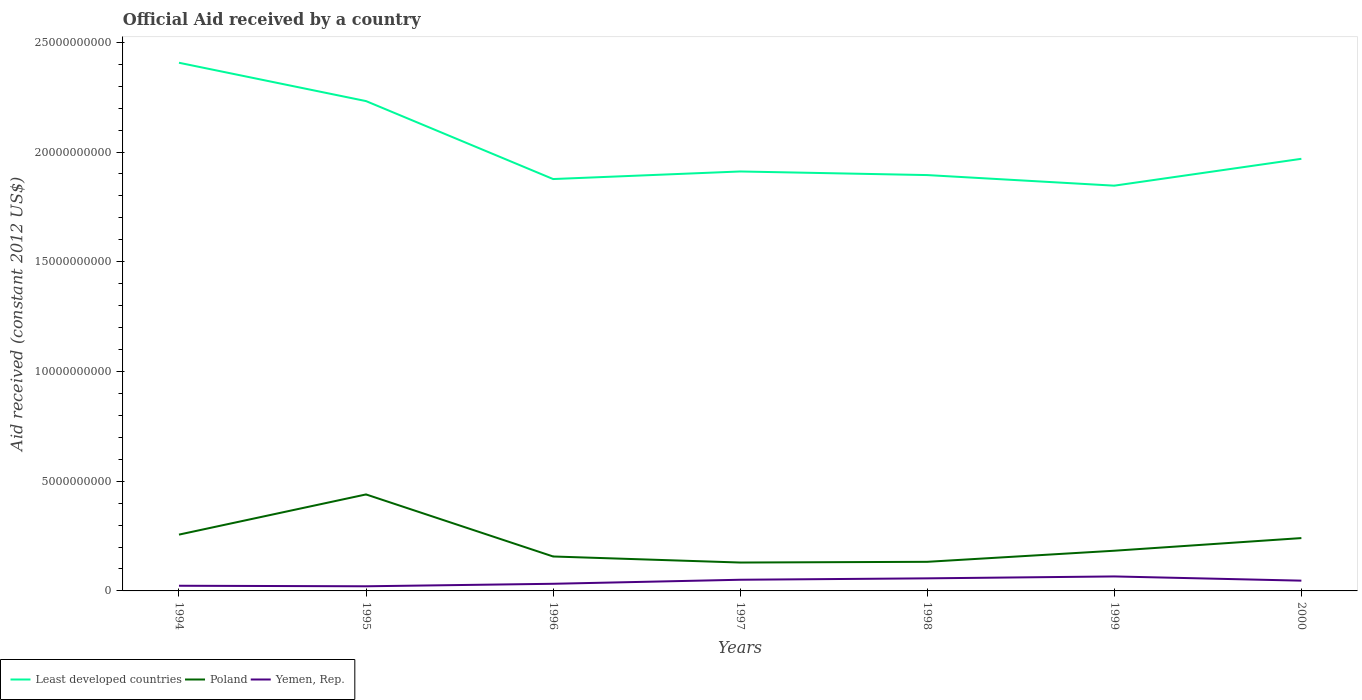Is the number of lines equal to the number of legend labels?
Keep it short and to the point. Yes. Across all years, what is the maximum net official aid received in Least developed countries?
Your answer should be compact. 1.85e+1. What is the total net official aid received in Least developed countries in the graph?
Make the answer very short. 4.38e+09. What is the difference between the highest and the second highest net official aid received in Poland?
Offer a very short reply. 3.10e+09. What is the difference between the highest and the lowest net official aid received in Poland?
Your answer should be very brief. 3. Is the net official aid received in Least developed countries strictly greater than the net official aid received in Yemen, Rep. over the years?
Your response must be concise. No. How many years are there in the graph?
Give a very brief answer. 7. What is the difference between two consecutive major ticks on the Y-axis?
Ensure brevity in your answer.  5.00e+09. Where does the legend appear in the graph?
Ensure brevity in your answer.  Bottom left. How many legend labels are there?
Provide a short and direct response. 3. How are the legend labels stacked?
Offer a terse response. Horizontal. What is the title of the graph?
Make the answer very short. Official Aid received by a country. Does "Channel Islands" appear as one of the legend labels in the graph?
Ensure brevity in your answer.  No. What is the label or title of the X-axis?
Make the answer very short. Years. What is the label or title of the Y-axis?
Offer a terse response. Aid received (constant 2012 US$). What is the Aid received (constant 2012 US$) in Least developed countries in 1994?
Keep it short and to the point. 2.41e+1. What is the Aid received (constant 2012 US$) in Poland in 1994?
Give a very brief answer. 2.57e+09. What is the Aid received (constant 2012 US$) of Yemen, Rep. in 1994?
Provide a short and direct response. 2.36e+08. What is the Aid received (constant 2012 US$) of Least developed countries in 1995?
Your answer should be compact. 2.23e+1. What is the Aid received (constant 2012 US$) in Poland in 1995?
Your response must be concise. 4.40e+09. What is the Aid received (constant 2012 US$) of Yemen, Rep. in 1995?
Keep it short and to the point. 2.12e+08. What is the Aid received (constant 2012 US$) in Least developed countries in 1996?
Give a very brief answer. 1.88e+1. What is the Aid received (constant 2012 US$) of Poland in 1996?
Make the answer very short. 1.57e+09. What is the Aid received (constant 2012 US$) of Yemen, Rep. in 1996?
Provide a succinct answer. 3.26e+08. What is the Aid received (constant 2012 US$) of Least developed countries in 1997?
Make the answer very short. 1.91e+1. What is the Aid received (constant 2012 US$) of Poland in 1997?
Your answer should be compact. 1.29e+09. What is the Aid received (constant 2012 US$) in Yemen, Rep. in 1997?
Your answer should be very brief. 5.09e+08. What is the Aid received (constant 2012 US$) in Least developed countries in 1998?
Keep it short and to the point. 1.89e+1. What is the Aid received (constant 2012 US$) of Poland in 1998?
Your response must be concise. 1.33e+09. What is the Aid received (constant 2012 US$) in Yemen, Rep. in 1998?
Your answer should be compact. 5.73e+08. What is the Aid received (constant 2012 US$) of Least developed countries in 1999?
Your response must be concise. 1.85e+1. What is the Aid received (constant 2012 US$) in Poland in 1999?
Ensure brevity in your answer.  1.83e+09. What is the Aid received (constant 2012 US$) of Yemen, Rep. in 1999?
Your answer should be very brief. 6.60e+08. What is the Aid received (constant 2012 US$) of Least developed countries in 2000?
Give a very brief answer. 1.97e+1. What is the Aid received (constant 2012 US$) of Poland in 2000?
Make the answer very short. 2.41e+09. What is the Aid received (constant 2012 US$) in Yemen, Rep. in 2000?
Provide a short and direct response. 4.68e+08. Across all years, what is the maximum Aid received (constant 2012 US$) in Least developed countries?
Your answer should be compact. 2.41e+1. Across all years, what is the maximum Aid received (constant 2012 US$) of Poland?
Provide a short and direct response. 4.40e+09. Across all years, what is the maximum Aid received (constant 2012 US$) in Yemen, Rep.?
Your answer should be very brief. 6.60e+08. Across all years, what is the minimum Aid received (constant 2012 US$) of Least developed countries?
Make the answer very short. 1.85e+1. Across all years, what is the minimum Aid received (constant 2012 US$) in Poland?
Your response must be concise. 1.29e+09. Across all years, what is the minimum Aid received (constant 2012 US$) in Yemen, Rep.?
Give a very brief answer. 2.12e+08. What is the total Aid received (constant 2012 US$) in Least developed countries in the graph?
Your answer should be very brief. 1.41e+11. What is the total Aid received (constant 2012 US$) in Poland in the graph?
Ensure brevity in your answer.  1.54e+1. What is the total Aid received (constant 2012 US$) of Yemen, Rep. in the graph?
Your response must be concise. 2.98e+09. What is the difference between the Aid received (constant 2012 US$) in Least developed countries in 1994 and that in 1995?
Offer a terse response. 1.75e+09. What is the difference between the Aid received (constant 2012 US$) of Poland in 1994 and that in 1995?
Your answer should be compact. -1.83e+09. What is the difference between the Aid received (constant 2012 US$) of Yemen, Rep. in 1994 and that in 1995?
Your answer should be compact. 2.44e+07. What is the difference between the Aid received (constant 2012 US$) of Least developed countries in 1994 and that in 1996?
Provide a short and direct response. 5.30e+09. What is the difference between the Aid received (constant 2012 US$) in Poland in 1994 and that in 1996?
Your response must be concise. 9.96e+08. What is the difference between the Aid received (constant 2012 US$) of Yemen, Rep. in 1994 and that in 1996?
Your answer should be compact. -8.98e+07. What is the difference between the Aid received (constant 2012 US$) of Least developed countries in 1994 and that in 1997?
Offer a terse response. 4.95e+09. What is the difference between the Aid received (constant 2012 US$) in Poland in 1994 and that in 1997?
Your response must be concise. 1.27e+09. What is the difference between the Aid received (constant 2012 US$) in Yemen, Rep. in 1994 and that in 1997?
Provide a succinct answer. -2.73e+08. What is the difference between the Aid received (constant 2012 US$) in Least developed countries in 1994 and that in 1998?
Keep it short and to the point. 5.12e+09. What is the difference between the Aid received (constant 2012 US$) in Poland in 1994 and that in 1998?
Provide a succinct answer. 1.24e+09. What is the difference between the Aid received (constant 2012 US$) of Yemen, Rep. in 1994 and that in 1998?
Offer a terse response. -3.37e+08. What is the difference between the Aid received (constant 2012 US$) of Least developed countries in 1994 and that in 1999?
Your answer should be compact. 5.60e+09. What is the difference between the Aid received (constant 2012 US$) in Poland in 1994 and that in 1999?
Make the answer very short. 7.34e+08. What is the difference between the Aid received (constant 2012 US$) of Yemen, Rep. in 1994 and that in 1999?
Keep it short and to the point. -4.24e+08. What is the difference between the Aid received (constant 2012 US$) of Least developed countries in 1994 and that in 2000?
Your answer should be very brief. 4.38e+09. What is the difference between the Aid received (constant 2012 US$) of Poland in 1994 and that in 2000?
Make the answer very short. 1.58e+08. What is the difference between the Aid received (constant 2012 US$) in Yemen, Rep. in 1994 and that in 2000?
Provide a succinct answer. -2.32e+08. What is the difference between the Aid received (constant 2012 US$) of Least developed countries in 1995 and that in 1996?
Keep it short and to the point. 3.55e+09. What is the difference between the Aid received (constant 2012 US$) in Poland in 1995 and that in 1996?
Your response must be concise. 2.83e+09. What is the difference between the Aid received (constant 2012 US$) of Yemen, Rep. in 1995 and that in 1996?
Keep it short and to the point. -1.14e+08. What is the difference between the Aid received (constant 2012 US$) of Least developed countries in 1995 and that in 1997?
Provide a short and direct response. 3.21e+09. What is the difference between the Aid received (constant 2012 US$) in Poland in 1995 and that in 1997?
Your response must be concise. 3.10e+09. What is the difference between the Aid received (constant 2012 US$) of Yemen, Rep. in 1995 and that in 1997?
Your response must be concise. -2.98e+08. What is the difference between the Aid received (constant 2012 US$) in Least developed countries in 1995 and that in 1998?
Ensure brevity in your answer.  3.37e+09. What is the difference between the Aid received (constant 2012 US$) of Poland in 1995 and that in 1998?
Give a very brief answer. 3.07e+09. What is the difference between the Aid received (constant 2012 US$) in Yemen, Rep. in 1995 and that in 1998?
Keep it short and to the point. -3.62e+08. What is the difference between the Aid received (constant 2012 US$) in Least developed countries in 1995 and that in 1999?
Make the answer very short. 3.85e+09. What is the difference between the Aid received (constant 2012 US$) of Poland in 1995 and that in 1999?
Ensure brevity in your answer.  2.57e+09. What is the difference between the Aid received (constant 2012 US$) in Yemen, Rep. in 1995 and that in 1999?
Give a very brief answer. -4.49e+08. What is the difference between the Aid received (constant 2012 US$) of Least developed countries in 1995 and that in 2000?
Make the answer very short. 2.63e+09. What is the difference between the Aid received (constant 2012 US$) of Poland in 1995 and that in 2000?
Offer a very short reply. 1.99e+09. What is the difference between the Aid received (constant 2012 US$) in Yemen, Rep. in 1995 and that in 2000?
Make the answer very short. -2.56e+08. What is the difference between the Aid received (constant 2012 US$) in Least developed countries in 1996 and that in 1997?
Offer a terse response. -3.45e+08. What is the difference between the Aid received (constant 2012 US$) of Poland in 1996 and that in 1997?
Provide a short and direct response. 2.76e+08. What is the difference between the Aid received (constant 2012 US$) of Yemen, Rep. in 1996 and that in 1997?
Make the answer very short. -1.83e+08. What is the difference between the Aid received (constant 2012 US$) of Least developed countries in 1996 and that in 1998?
Offer a very short reply. -1.81e+08. What is the difference between the Aid received (constant 2012 US$) in Poland in 1996 and that in 1998?
Your answer should be very brief. 2.43e+08. What is the difference between the Aid received (constant 2012 US$) of Yemen, Rep. in 1996 and that in 1998?
Provide a succinct answer. -2.48e+08. What is the difference between the Aid received (constant 2012 US$) of Least developed countries in 1996 and that in 1999?
Keep it short and to the point. 3.02e+08. What is the difference between the Aid received (constant 2012 US$) in Poland in 1996 and that in 1999?
Keep it short and to the point. -2.62e+08. What is the difference between the Aid received (constant 2012 US$) of Yemen, Rep. in 1996 and that in 1999?
Your answer should be compact. -3.34e+08. What is the difference between the Aid received (constant 2012 US$) of Least developed countries in 1996 and that in 2000?
Provide a short and direct response. -9.22e+08. What is the difference between the Aid received (constant 2012 US$) in Poland in 1996 and that in 2000?
Offer a terse response. -8.38e+08. What is the difference between the Aid received (constant 2012 US$) of Yemen, Rep. in 1996 and that in 2000?
Provide a succinct answer. -1.42e+08. What is the difference between the Aid received (constant 2012 US$) in Least developed countries in 1997 and that in 1998?
Your answer should be compact. 1.64e+08. What is the difference between the Aid received (constant 2012 US$) in Poland in 1997 and that in 1998?
Provide a short and direct response. -3.26e+07. What is the difference between the Aid received (constant 2012 US$) of Yemen, Rep. in 1997 and that in 1998?
Your response must be concise. -6.40e+07. What is the difference between the Aid received (constant 2012 US$) in Least developed countries in 1997 and that in 1999?
Offer a very short reply. 6.47e+08. What is the difference between the Aid received (constant 2012 US$) of Poland in 1997 and that in 1999?
Make the answer very short. -5.38e+08. What is the difference between the Aid received (constant 2012 US$) of Yemen, Rep. in 1997 and that in 1999?
Your answer should be very brief. -1.51e+08. What is the difference between the Aid received (constant 2012 US$) of Least developed countries in 1997 and that in 2000?
Your answer should be compact. -5.77e+08. What is the difference between the Aid received (constant 2012 US$) in Poland in 1997 and that in 2000?
Keep it short and to the point. -1.11e+09. What is the difference between the Aid received (constant 2012 US$) of Yemen, Rep. in 1997 and that in 2000?
Offer a terse response. 4.11e+07. What is the difference between the Aid received (constant 2012 US$) of Least developed countries in 1998 and that in 1999?
Your answer should be compact. 4.83e+08. What is the difference between the Aid received (constant 2012 US$) in Poland in 1998 and that in 1999?
Provide a succinct answer. -5.05e+08. What is the difference between the Aid received (constant 2012 US$) in Yemen, Rep. in 1998 and that in 1999?
Give a very brief answer. -8.70e+07. What is the difference between the Aid received (constant 2012 US$) in Least developed countries in 1998 and that in 2000?
Your answer should be very brief. -7.42e+08. What is the difference between the Aid received (constant 2012 US$) in Poland in 1998 and that in 2000?
Your answer should be very brief. -1.08e+09. What is the difference between the Aid received (constant 2012 US$) of Yemen, Rep. in 1998 and that in 2000?
Ensure brevity in your answer.  1.05e+08. What is the difference between the Aid received (constant 2012 US$) in Least developed countries in 1999 and that in 2000?
Make the answer very short. -1.22e+09. What is the difference between the Aid received (constant 2012 US$) in Poland in 1999 and that in 2000?
Offer a very short reply. -5.76e+08. What is the difference between the Aid received (constant 2012 US$) in Yemen, Rep. in 1999 and that in 2000?
Your response must be concise. 1.92e+08. What is the difference between the Aid received (constant 2012 US$) of Least developed countries in 1994 and the Aid received (constant 2012 US$) of Poland in 1995?
Your answer should be very brief. 1.97e+1. What is the difference between the Aid received (constant 2012 US$) of Least developed countries in 1994 and the Aid received (constant 2012 US$) of Yemen, Rep. in 1995?
Provide a short and direct response. 2.39e+1. What is the difference between the Aid received (constant 2012 US$) in Poland in 1994 and the Aid received (constant 2012 US$) in Yemen, Rep. in 1995?
Provide a short and direct response. 2.35e+09. What is the difference between the Aid received (constant 2012 US$) in Least developed countries in 1994 and the Aid received (constant 2012 US$) in Poland in 1996?
Provide a short and direct response. 2.25e+1. What is the difference between the Aid received (constant 2012 US$) of Least developed countries in 1994 and the Aid received (constant 2012 US$) of Yemen, Rep. in 1996?
Your answer should be very brief. 2.37e+1. What is the difference between the Aid received (constant 2012 US$) in Poland in 1994 and the Aid received (constant 2012 US$) in Yemen, Rep. in 1996?
Your answer should be compact. 2.24e+09. What is the difference between the Aid received (constant 2012 US$) in Least developed countries in 1994 and the Aid received (constant 2012 US$) in Poland in 1997?
Offer a terse response. 2.28e+1. What is the difference between the Aid received (constant 2012 US$) in Least developed countries in 1994 and the Aid received (constant 2012 US$) in Yemen, Rep. in 1997?
Make the answer very short. 2.36e+1. What is the difference between the Aid received (constant 2012 US$) in Poland in 1994 and the Aid received (constant 2012 US$) in Yemen, Rep. in 1997?
Ensure brevity in your answer.  2.06e+09. What is the difference between the Aid received (constant 2012 US$) of Least developed countries in 1994 and the Aid received (constant 2012 US$) of Poland in 1998?
Ensure brevity in your answer.  2.27e+1. What is the difference between the Aid received (constant 2012 US$) of Least developed countries in 1994 and the Aid received (constant 2012 US$) of Yemen, Rep. in 1998?
Make the answer very short. 2.35e+1. What is the difference between the Aid received (constant 2012 US$) in Poland in 1994 and the Aid received (constant 2012 US$) in Yemen, Rep. in 1998?
Offer a terse response. 1.99e+09. What is the difference between the Aid received (constant 2012 US$) of Least developed countries in 1994 and the Aid received (constant 2012 US$) of Poland in 1999?
Your answer should be very brief. 2.22e+1. What is the difference between the Aid received (constant 2012 US$) in Least developed countries in 1994 and the Aid received (constant 2012 US$) in Yemen, Rep. in 1999?
Provide a short and direct response. 2.34e+1. What is the difference between the Aid received (constant 2012 US$) in Poland in 1994 and the Aid received (constant 2012 US$) in Yemen, Rep. in 1999?
Provide a succinct answer. 1.91e+09. What is the difference between the Aid received (constant 2012 US$) in Least developed countries in 1994 and the Aid received (constant 2012 US$) in Poland in 2000?
Your answer should be compact. 2.17e+1. What is the difference between the Aid received (constant 2012 US$) of Least developed countries in 1994 and the Aid received (constant 2012 US$) of Yemen, Rep. in 2000?
Provide a succinct answer. 2.36e+1. What is the difference between the Aid received (constant 2012 US$) of Poland in 1994 and the Aid received (constant 2012 US$) of Yemen, Rep. in 2000?
Your answer should be very brief. 2.10e+09. What is the difference between the Aid received (constant 2012 US$) of Least developed countries in 1995 and the Aid received (constant 2012 US$) of Poland in 1996?
Offer a terse response. 2.08e+1. What is the difference between the Aid received (constant 2012 US$) of Least developed countries in 1995 and the Aid received (constant 2012 US$) of Yemen, Rep. in 1996?
Keep it short and to the point. 2.20e+1. What is the difference between the Aid received (constant 2012 US$) in Poland in 1995 and the Aid received (constant 2012 US$) in Yemen, Rep. in 1996?
Offer a terse response. 4.07e+09. What is the difference between the Aid received (constant 2012 US$) in Least developed countries in 1995 and the Aid received (constant 2012 US$) in Poland in 1997?
Your response must be concise. 2.10e+1. What is the difference between the Aid received (constant 2012 US$) in Least developed countries in 1995 and the Aid received (constant 2012 US$) in Yemen, Rep. in 1997?
Give a very brief answer. 2.18e+1. What is the difference between the Aid received (constant 2012 US$) of Poland in 1995 and the Aid received (constant 2012 US$) of Yemen, Rep. in 1997?
Offer a very short reply. 3.89e+09. What is the difference between the Aid received (constant 2012 US$) of Least developed countries in 1995 and the Aid received (constant 2012 US$) of Poland in 1998?
Ensure brevity in your answer.  2.10e+1. What is the difference between the Aid received (constant 2012 US$) of Least developed countries in 1995 and the Aid received (constant 2012 US$) of Yemen, Rep. in 1998?
Keep it short and to the point. 2.17e+1. What is the difference between the Aid received (constant 2012 US$) of Poland in 1995 and the Aid received (constant 2012 US$) of Yemen, Rep. in 1998?
Your answer should be compact. 3.82e+09. What is the difference between the Aid received (constant 2012 US$) in Least developed countries in 1995 and the Aid received (constant 2012 US$) in Poland in 1999?
Your answer should be very brief. 2.05e+1. What is the difference between the Aid received (constant 2012 US$) of Least developed countries in 1995 and the Aid received (constant 2012 US$) of Yemen, Rep. in 1999?
Make the answer very short. 2.17e+1. What is the difference between the Aid received (constant 2012 US$) of Poland in 1995 and the Aid received (constant 2012 US$) of Yemen, Rep. in 1999?
Your answer should be very brief. 3.74e+09. What is the difference between the Aid received (constant 2012 US$) of Least developed countries in 1995 and the Aid received (constant 2012 US$) of Poland in 2000?
Your response must be concise. 1.99e+1. What is the difference between the Aid received (constant 2012 US$) of Least developed countries in 1995 and the Aid received (constant 2012 US$) of Yemen, Rep. in 2000?
Offer a very short reply. 2.19e+1. What is the difference between the Aid received (constant 2012 US$) of Poland in 1995 and the Aid received (constant 2012 US$) of Yemen, Rep. in 2000?
Your answer should be compact. 3.93e+09. What is the difference between the Aid received (constant 2012 US$) of Least developed countries in 1996 and the Aid received (constant 2012 US$) of Poland in 1997?
Make the answer very short. 1.75e+1. What is the difference between the Aid received (constant 2012 US$) in Least developed countries in 1996 and the Aid received (constant 2012 US$) in Yemen, Rep. in 1997?
Offer a terse response. 1.83e+1. What is the difference between the Aid received (constant 2012 US$) in Poland in 1996 and the Aid received (constant 2012 US$) in Yemen, Rep. in 1997?
Your answer should be compact. 1.06e+09. What is the difference between the Aid received (constant 2012 US$) of Least developed countries in 1996 and the Aid received (constant 2012 US$) of Poland in 1998?
Your response must be concise. 1.74e+1. What is the difference between the Aid received (constant 2012 US$) of Least developed countries in 1996 and the Aid received (constant 2012 US$) of Yemen, Rep. in 1998?
Offer a terse response. 1.82e+1. What is the difference between the Aid received (constant 2012 US$) of Poland in 1996 and the Aid received (constant 2012 US$) of Yemen, Rep. in 1998?
Make the answer very short. 9.96e+08. What is the difference between the Aid received (constant 2012 US$) of Least developed countries in 1996 and the Aid received (constant 2012 US$) of Poland in 1999?
Offer a terse response. 1.69e+1. What is the difference between the Aid received (constant 2012 US$) in Least developed countries in 1996 and the Aid received (constant 2012 US$) in Yemen, Rep. in 1999?
Your answer should be compact. 1.81e+1. What is the difference between the Aid received (constant 2012 US$) of Poland in 1996 and the Aid received (constant 2012 US$) of Yemen, Rep. in 1999?
Your answer should be very brief. 9.09e+08. What is the difference between the Aid received (constant 2012 US$) of Least developed countries in 1996 and the Aid received (constant 2012 US$) of Poland in 2000?
Provide a succinct answer. 1.64e+1. What is the difference between the Aid received (constant 2012 US$) of Least developed countries in 1996 and the Aid received (constant 2012 US$) of Yemen, Rep. in 2000?
Offer a very short reply. 1.83e+1. What is the difference between the Aid received (constant 2012 US$) in Poland in 1996 and the Aid received (constant 2012 US$) in Yemen, Rep. in 2000?
Provide a short and direct response. 1.10e+09. What is the difference between the Aid received (constant 2012 US$) in Least developed countries in 1997 and the Aid received (constant 2012 US$) in Poland in 1998?
Keep it short and to the point. 1.78e+1. What is the difference between the Aid received (constant 2012 US$) of Least developed countries in 1997 and the Aid received (constant 2012 US$) of Yemen, Rep. in 1998?
Offer a terse response. 1.85e+1. What is the difference between the Aid received (constant 2012 US$) in Poland in 1997 and the Aid received (constant 2012 US$) in Yemen, Rep. in 1998?
Provide a short and direct response. 7.21e+08. What is the difference between the Aid received (constant 2012 US$) in Least developed countries in 1997 and the Aid received (constant 2012 US$) in Poland in 1999?
Give a very brief answer. 1.73e+1. What is the difference between the Aid received (constant 2012 US$) of Least developed countries in 1997 and the Aid received (constant 2012 US$) of Yemen, Rep. in 1999?
Offer a very short reply. 1.85e+1. What is the difference between the Aid received (constant 2012 US$) in Poland in 1997 and the Aid received (constant 2012 US$) in Yemen, Rep. in 1999?
Offer a terse response. 6.34e+08. What is the difference between the Aid received (constant 2012 US$) of Least developed countries in 1997 and the Aid received (constant 2012 US$) of Poland in 2000?
Provide a short and direct response. 1.67e+1. What is the difference between the Aid received (constant 2012 US$) in Least developed countries in 1997 and the Aid received (constant 2012 US$) in Yemen, Rep. in 2000?
Provide a succinct answer. 1.86e+1. What is the difference between the Aid received (constant 2012 US$) in Poland in 1997 and the Aid received (constant 2012 US$) in Yemen, Rep. in 2000?
Offer a terse response. 8.26e+08. What is the difference between the Aid received (constant 2012 US$) of Least developed countries in 1998 and the Aid received (constant 2012 US$) of Poland in 1999?
Provide a succinct answer. 1.71e+1. What is the difference between the Aid received (constant 2012 US$) in Least developed countries in 1998 and the Aid received (constant 2012 US$) in Yemen, Rep. in 1999?
Keep it short and to the point. 1.83e+1. What is the difference between the Aid received (constant 2012 US$) in Poland in 1998 and the Aid received (constant 2012 US$) in Yemen, Rep. in 1999?
Offer a terse response. 6.66e+08. What is the difference between the Aid received (constant 2012 US$) in Least developed countries in 1998 and the Aid received (constant 2012 US$) in Poland in 2000?
Keep it short and to the point. 1.65e+1. What is the difference between the Aid received (constant 2012 US$) of Least developed countries in 1998 and the Aid received (constant 2012 US$) of Yemen, Rep. in 2000?
Your response must be concise. 1.85e+1. What is the difference between the Aid received (constant 2012 US$) in Poland in 1998 and the Aid received (constant 2012 US$) in Yemen, Rep. in 2000?
Provide a succinct answer. 8.59e+08. What is the difference between the Aid received (constant 2012 US$) of Least developed countries in 1999 and the Aid received (constant 2012 US$) of Poland in 2000?
Your answer should be compact. 1.61e+1. What is the difference between the Aid received (constant 2012 US$) in Least developed countries in 1999 and the Aid received (constant 2012 US$) in Yemen, Rep. in 2000?
Make the answer very short. 1.80e+1. What is the difference between the Aid received (constant 2012 US$) in Poland in 1999 and the Aid received (constant 2012 US$) in Yemen, Rep. in 2000?
Keep it short and to the point. 1.36e+09. What is the average Aid received (constant 2012 US$) in Least developed countries per year?
Give a very brief answer. 2.02e+1. What is the average Aid received (constant 2012 US$) in Poland per year?
Give a very brief answer. 2.20e+09. What is the average Aid received (constant 2012 US$) in Yemen, Rep. per year?
Give a very brief answer. 4.26e+08. In the year 1994, what is the difference between the Aid received (constant 2012 US$) in Least developed countries and Aid received (constant 2012 US$) in Poland?
Your answer should be very brief. 2.15e+1. In the year 1994, what is the difference between the Aid received (constant 2012 US$) in Least developed countries and Aid received (constant 2012 US$) in Yemen, Rep.?
Offer a very short reply. 2.38e+1. In the year 1994, what is the difference between the Aid received (constant 2012 US$) of Poland and Aid received (constant 2012 US$) of Yemen, Rep.?
Provide a succinct answer. 2.33e+09. In the year 1995, what is the difference between the Aid received (constant 2012 US$) in Least developed countries and Aid received (constant 2012 US$) in Poland?
Give a very brief answer. 1.79e+1. In the year 1995, what is the difference between the Aid received (constant 2012 US$) in Least developed countries and Aid received (constant 2012 US$) in Yemen, Rep.?
Provide a succinct answer. 2.21e+1. In the year 1995, what is the difference between the Aid received (constant 2012 US$) of Poland and Aid received (constant 2012 US$) of Yemen, Rep.?
Offer a very short reply. 4.19e+09. In the year 1996, what is the difference between the Aid received (constant 2012 US$) of Least developed countries and Aid received (constant 2012 US$) of Poland?
Your answer should be very brief. 1.72e+1. In the year 1996, what is the difference between the Aid received (constant 2012 US$) of Least developed countries and Aid received (constant 2012 US$) of Yemen, Rep.?
Make the answer very short. 1.84e+1. In the year 1996, what is the difference between the Aid received (constant 2012 US$) in Poland and Aid received (constant 2012 US$) in Yemen, Rep.?
Ensure brevity in your answer.  1.24e+09. In the year 1997, what is the difference between the Aid received (constant 2012 US$) in Least developed countries and Aid received (constant 2012 US$) in Poland?
Your answer should be compact. 1.78e+1. In the year 1997, what is the difference between the Aid received (constant 2012 US$) of Least developed countries and Aid received (constant 2012 US$) of Yemen, Rep.?
Ensure brevity in your answer.  1.86e+1. In the year 1997, what is the difference between the Aid received (constant 2012 US$) in Poland and Aid received (constant 2012 US$) in Yemen, Rep.?
Your response must be concise. 7.85e+08. In the year 1998, what is the difference between the Aid received (constant 2012 US$) in Least developed countries and Aid received (constant 2012 US$) in Poland?
Your answer should be compact. 1.76e+1. In the year 1998, what is the difference between the Aid received (constant 2012 US$) in Least developed countries and Aid received (constant 2012 US$) in Yemen, Rep.?
Offer a very short reply. 1.84e+1. In the year 1998, what is the difference between the Aid received (constant 2012 US$) of Poland and Aid received (constant 2012 US$) of Yemen, Rep.?
Your answer should be very brief. 7.53e+08. In the year 1999, what is the difference between the Aid received (constant 2012 US$) of Least developed countries and Aid received (constant 2012 US$) of Poland?
Offer a terse response. 1.66e+1. In the year 1999, what is the difference between the Aid received (constant 2012 US$) of Least developed countries and Aid received (constant 2012 US$) of Yemen, Rep.?
Offer a terse response. 1.78e+1. In the year 1999, what is the difference between the Aid received (constant 2012 US$) in Poland and Aid received (constant 2012 US$) in Yemen, Rep.?
Offer a very short reply. 1.17e+09. In the year 2000, what is the difference between the Aid received (constant 2012 US$) of Least developed countries and Aid received (constant 2012 US$) of Poland?
Your answer should be very brief. 1.73e+1. In the year 2000, what is the difference between the Aid received (constant 2012 US$) in Least developed countries and Aid received (constant 2012 US$) in Yemen, Rep.?
Your answer should be very brief. 1.92e+1. In the year 2000, what is the difference between the Aid received (constant 2012 US$) of Poland and Aid received (constant 2012 US$) of Yemen, Rep.?
Provide a succinct answer. 1.94e+09. What is the ratio of the Aid received (constant 2012 US$) of Least developed countries in 1994 to that in 1995?
Offer a terse response. 1.08. What is the ratio of the Aid received (constant 2012 US$) of Poland in 1994 to that in 1995?
Your answer should be very brief. 0.58. What is the ratio of the Aid received (constant 2012 US$) of Yemen, Rep. in 1994 to that in 1995?
Your response must be concise. 1.12. What is the ratio of the Aid received (constant 2012 US$) of Least developed countries in 1994 to that in 1996?
Provide a succinct answer. 1.28. What is the ratio of the Aid received (constant 2012 US$) of Poland in 1994 to that in 1996?
Your answer should be very brief. 1.63. What is the ratio of the Aid received (constant 2012 US$) of Yemen, Rep. in 1994 to that in 1996?
Your answer should be very brief. 0.72. What is the ratio of the Aid received (constant 2012 US$) of Least developed countries in 1994 to that in 1997?
Ensure brevity in your answer.  1.26. What is the ratio of the Aid received (constant 2012 US$) of Poland in 1994 to that in 1997?
Provide a succinct answer. 1.98. What is the ratio of the Aid received (constant 2012 US$) in Yemen, Rep. in 1994 to that in 1997?
Provide a succinct answer. 0.46. What is the ratio of the Aid received (constant 2012 US$) in Least developed countries in 1994 to that in 1998?
Your response must be concise. 1.27. What is the ratio of the Aid received (constant 2012 US$) of Poland in 1994 to that in 1998?
Your answer should be very brief. 1.93. What is the ratio of the Aid received (constant 2012 US$) of Yemen, Rep. in 1994 to that in 1998?
Offer a very short reply. 0.41. What is the ratio of the Aid received (constant 2012 US$) in Least developed countries in 1994 to that in 1999?
Offer a terse response. 1.3. What is the ratio of the Aid received (constant 2012 US$) of Poland in 1994 to that in 1999?
Keep it short and to the point. 1.4. What is the ratio of the Aid received (constant 2012 US$) in Yemen, Rep. in 1994 to that in 1999?
Your answer should be compact. 0.36. What is the ratio of the Aid received (constant 2012 US$) of Least developed countries in 1994 to that in 2000?
Keep it short and to the point. 1.22. What is the ratio of the Aid received (constant 2012 US$) of Poland in 1994 to that in 2000?
Your response must be concise. 1.07. What is the ratio of the Aid received (constant 2012 US$) of Yemen, Rep. in 1994 to that in 2000?
Provide a short and direct response. 0.5. What is the ratio of the Aid received (constant 2012 US$) in Least developed countries in 1995 to that in 1996?
Your answer should be very brief. 1.19. What is the ratio of the Aid received (constant 2012 US$) of Poland in 1995 to that in 1996?
Provide a succinct answer. 2.8. What is the ratio of the Aid received (constant 2012 US$) of Yemen, Rep. in 1995 to that in 1996?
Offer a very short reply. 0.65. What is the ratio of the Aid received (constant 2012 US$) in Least developed countries in 1995 to that in 1997?
Provide a succinct answer. 1.17. What is the ratio of the Aid received (constant 2012 US$) in Poland in 1995 to that in 1997?
Keep it short and to the point. 3.4. What is the ratio of the Aid received (constant 2012 US$) in Yemen, Rep. in 1995 to that in 1997?
Offer a terse response. 0.42. What is the ratio of the Aid received (constant 2012 US$) in Least developed countries in 1995 to that in 1998?
Give a very brief answer. 1.18. What is the ratio of the Aid received (constant 2012 US$) in Poland in 1995 to that in 1998?
Ensure brevity in your answer.  3.31. What is the ratio of the Aid received (constant 2012 US$) of Yemen, Rep. in 1995 to that in 1998?
Make the answer very short. 0.37. What is the ratio of the Aid received (constant 2012 US$) in Least developed countries in 1995 to that in 1999?
Give a very brief answer. 1.21. What is the ratio of the Aid received (constant 2012 US$) of Poland in 1995 to that in 1999?
Your answer should be compact. 2.4. What is the ratio of the Aid received (constant 2012 US$) of Yemen, Rep. in 1995 to that in 1999?
Your response must be concise. 0.32. What is the ratio of the Aid received (constant 2012 US$) in Least developed countries in 1995 to that in 2000?
Your response must be concise. 1.13. What is the ratio of the Aid received (constant 2012 US$) in Poland in 1995 to that in 2000?
Keep it short and to the point. 1.83. What is the ratio of the Aid received (constant 2012 US$) of Yemen, Rep. in 1995 to that in 2000?
Your answer should be very brief. 0.45. What is the ratio of the Aid received (constant 2012 US$) of Least developed countries in 1996 to that in 1997?
Make the answer very short. 0.98. What is the ratio of the Aid received (constant 2012 US$) of Poland in 1996 to that in 1997?
Offer a very short reply. 1.21. What is the ratio of the Aid received (constant 2012 US$) of Yemen, Rep. in 1996 to that in 1997?
Offer a very short reply. 0.64. What is the ratio of the Aid received (constant 2012 US$) in Poland in 1996 to that in 1998?
Your answer should be very brief. 1.18. What is the ratio of the Aid received (constant 2012 US$) in Yemen, Rep. in 1996 to that in 1998?
Keep it short and to the point. 0.57. What is the ratio of the Aid received (constant 2012 US$) of Least developed countries in 1996 to that in 1999?
Your response must be concise. 1.02. What is the ratio of the Aid received (constant 2012 US$) in Poland in 1996 to that in 1999?
Your answer should be very brief. 0.86. What is the ratio of the Aid received (constant 2012 US$) of Yemen, Rep. in 1996 to that in 1999?
Keep it short and to the point. 0.49. What is the ratio of the Aid received (constant 2012 US$) in Least developed countries in 1996 to that in 2000?
Give a very brief answer. 0.95. What is the ratio of the Aid received (constant 2012 US$) of Poland in 1996 to that in 2000?
Ensure brevity in your answer.  0.65. What is the ratio of the Aid received (constant 2012 US$) of Yemen, Rep. in 1996 to that in 2000?
Your answer should be compact. 0.7. What is the ratio of the Aid received (constant 2012 US$) of Least developed countries in 1997 to that in 1998?
Your response must be concise. 1.01. What is the ratio of the Aid received (constant 2012 US$) in Poland in 1997 to that in 1998?
Provide a short and direct response. 0.98. What is the ratio of the Aid received (constant 2012 US$) of Yemen, Rep. in 1997 to that in 1998?
Your answer should be very brief. 0.89. What is the ratio of the Aid received (constant 2012 US$) in Least developed countries in 1997 to that in 1999?
Offer a very short reply. 1.03. What is the ratio of the Aid received (constant 2012 US$) in Poland in 1997 to that in 1999?
Provide a short and direct response. 0.71. What is the ratio of the Aid received (constant 2012 US$) of Yemen, Rep. in 1997 to that in 1999?
Your response must be concise. 0.77. What is the ratio of the Aid received (constant 2012 US$) in Least developed countries in 1997 to that in 2000?
Make the answer very short. 0.97. What is the ratio of the Aid received (constant 2012 US$) in Poland in 1997 to that in 2000?
Ensure brevity in your answer.  0.54. What is the ratio of the Aid received (constant 2012 US$) in Yemen, Rep. in 1997 to that in 2000?
Keep it short and to the point. 1.09. What is the ratio of the Aid received (constant 2012 US$) of Least developed countries in 1998 to that in 1999?
Your response must be concise. 1.03. What is the ratio of the Aid received (constant 2012 US$) in Poland in 1998 to that in 1999?
Make the answer very short. 0.72. What is the ratio of the Aid received (constant 2012 US$) in Yemen, Rep. in 1998 to that in 1999?
Provide a succinct answer. 0.87. What is the ratio of the Aid received (constant 2012 US$) in Least developed countries in 1998 to that in 2000?
Give a very brief answer. 0.96. What is the ratio of the Aid received (constant 2012 US$) of Poland in 1998 to that in 2000?
Your answer should be very brief. 0.55. What is the ratio of the Aid received (constant 2012 US$) of Yemen, Rep. in 1998 to that in 2000?
Ensure brevity in your answer.  1.22. What is the ratio of the Aid received (constant 2012 US$) in Least developed countries in 1999 to that in 2000?
Offer a terse response. 0.94. What is the ratio of the Aid received (constant 2012 US$) of Poland in 1999 to that in 2000?
Your response must be concise. 0.76. What is the ratio of the Aid received (constant 2012 US$) of Yemen, Rep. in 1999 to that in 2000?
Your response must be concise. 1.41. What is the difference between the highest and the second highest Aid received (constant 2012 US$) in Least developed countries?
Provide a short and direct response. 1.75e+09. What is the difference between the highest and the second highest Aid received (constant 2012 US$) in Poland?
Give a very brief answer. 1.83e+09. What is the difference between the highest and the second highest Aid received (constant 2012 US$) in Yemen, Rep.?
Offer a very short reply. 8.70e+07. What is the difference between the highest and the lowest Aid received (constant 2012 US$) in Least developed countries?
Offer a very short reply. 5.60e+09. What is the difference between the highest and the lowest Aid received (constant 2012 US$) of Poland?
Ensure brevity in your answer.  3.10e+09. What is the difference between the highest and the lowest Aid received (constant 2012 US$) of Yemen, Rep.?
Ensure brevity in your answer.  4.49e+08. 